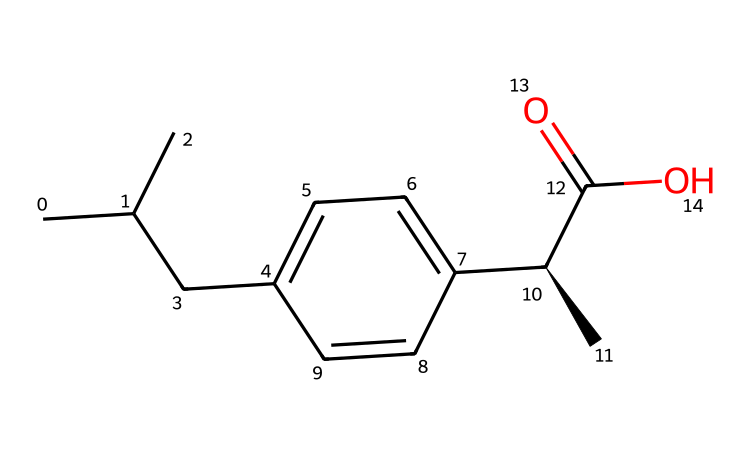What is the total number of carbon atoms in ibuprofen? By examining the SMILES representation, we can count the carbon atoms. There are a total of 13 carbon atoms in the provided structure.
Answer: 13 How many chiral centers are present in ibuprofen? Looking at the structure, there is one chiral center indicated by the notation [C@H], meaning there is one carbon atom that is bonded to four different substituents.
Answer: 1 What functional group is represented by the –C(=O)O portion of the structure? The structure –C(=O)O indicates a carboxylic acid functional group, which consists of a carbonyl group (C=O) and a hydroxyl group (–OH).
Answer: carboxylic acid What type of molecular interaction would likely play a significant role in ibuprofen's anti-inflammatory properties? The presence of multiple functional groups, particularly the carboxylic acid, allows for hydrogen bonding with biological molecules, which is crucial for ibuprofen's activity.
Answer: hydrogen bonding What is the molecular formula of ibuprofen based on the SMILES provided? From the count of each type of atom in the SMILES, we get the molecular formula C13H18O2, which represents the number of carbon, hydrogen, and oxygen atoms respectively.
Answer: C13H18O2 Which structure portion indicates the presence of an aromatic ring? The label "c" in the SMILES suggests the presence of carbon atoms in a cyclic, conjugated system, characteristic of aromatic compounds.
Answer: aromatic ring 